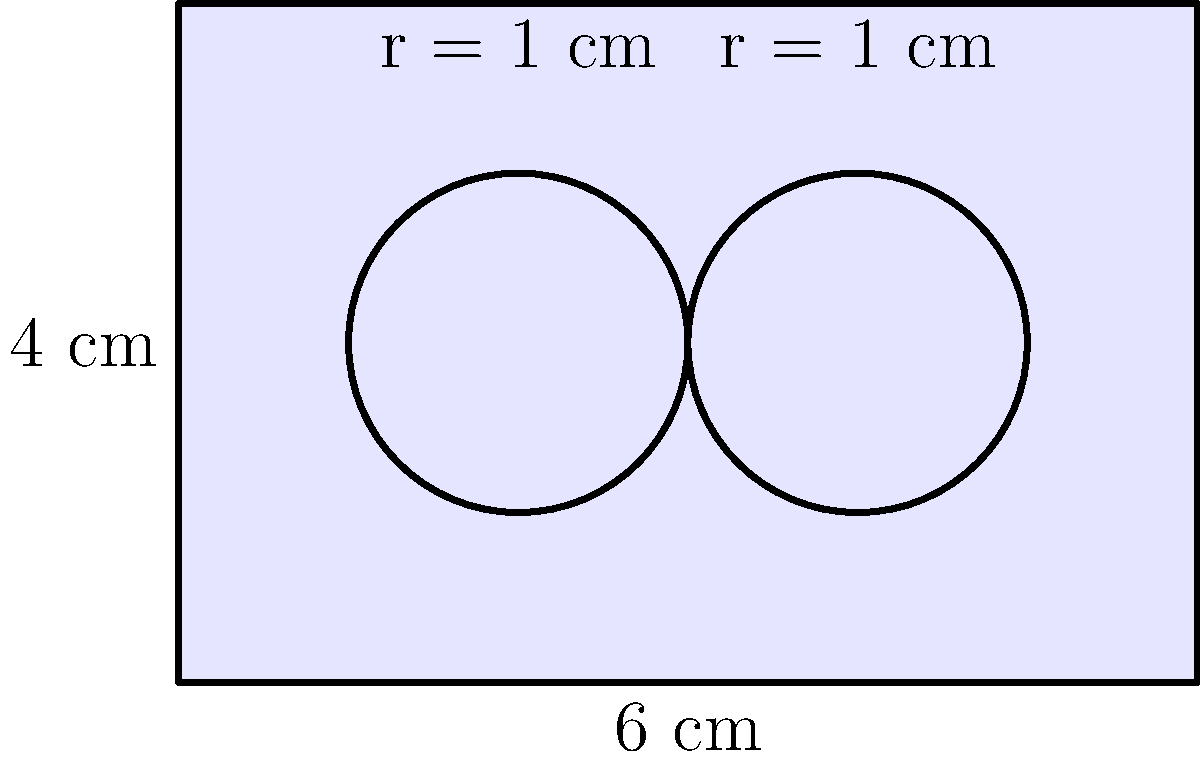In this intriguing shape, we have a rectangle with two circular cutouts. The rectangle measures 6 cm by 4 cm, and each circle has a radius of 1 cm. What is the area of the shaded region? Round your answer to two decimal places. To find the area of the shaded region, we need to follow these steps:

1) Calculate the area of the rectangle:
   $$A_{rectangle} = 6 \text{ cm} \times 4 \text{ cm} = 24 \text{ cm}^2$$

2) Calculate the area of one circle:
   $$A_{circle} = \pi r^2 = \pi (1 \text{ cm})^2 = \pi \text{ cm}^2$$

3) Calculate the area of both circles:
   $$A_{two circles} = 2 \pi \text{ cm}^2$$

4) Subtract the area of the circles from the area of the rectangle:
   $$A_{shaded} = A_{rectangle} - A_{two circles}$$
   $$A_{shaded} = 24 \text{ cm}^2 - 2\pi \text{ cm}^2$$
   $$A_{shaded} = (24 - 2\pi) \text{ cm}^2$$

5) Evaluate and round to two decimal places:
   $$A_{shaded} \approx 17.72 \text{ cm}^2$$

Therefore, the area of the shaded region is approximately 17.72 square centimeters.
Answer: 17.72 cm² 